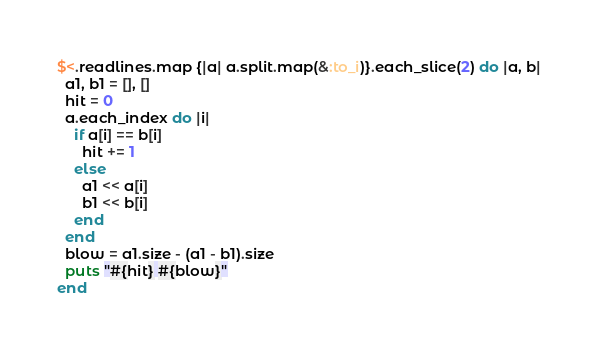Convert code to text. <code><loc_0><loc_0><loc_500><loc_500><_Ruby_>$<.readlines.map {|a| a.split.map(&:to_i)}.each_slice(2) do |a, b|
  a1, b1 = [], []
  hit = 0
  a.each_index do |i|
    if a[i] == b[i]
      hit += 1
    else
      a1 << a[i]
      b1 << b[i]
    end
  end
  blow = a1.size - (a1 - b1).size
  puts "#{hit} #{blow}"
end
</code> 